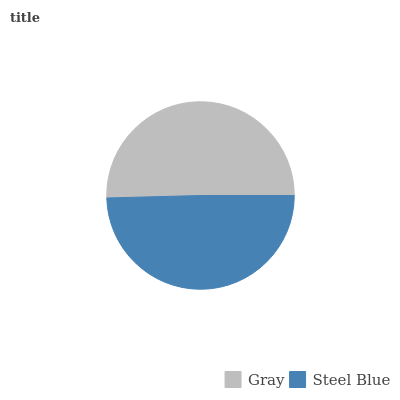Is Steel Blue the minimum?
Answer yes or no. Yes. Is Gray the maximum?
Answer yes or no. Yes. Is Steel Blue the maximum?
Answer yes or no. No. Is Gray greater than Steel Blue?
Answer yes or no. Yes. Is Steel Blue less than Gray?
Answer yes or no. Yes. Is Steel Blue greater than Gray?
Answer yes or no. No. Is Gray less than Steel Blue?
Answer yes or no. No. Is Gray the high median?
Answer yes or no. Yes. Is Steel Blue the low median?
Answer yes or no. Yes. Is Steel Blue the high median?
Answer yes or no. No. Is Gray the low median?
Answer yes or no. No. 